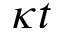<formula> <loc_0><loc_0><loc_500><loc_500>\kappa t</formula> 